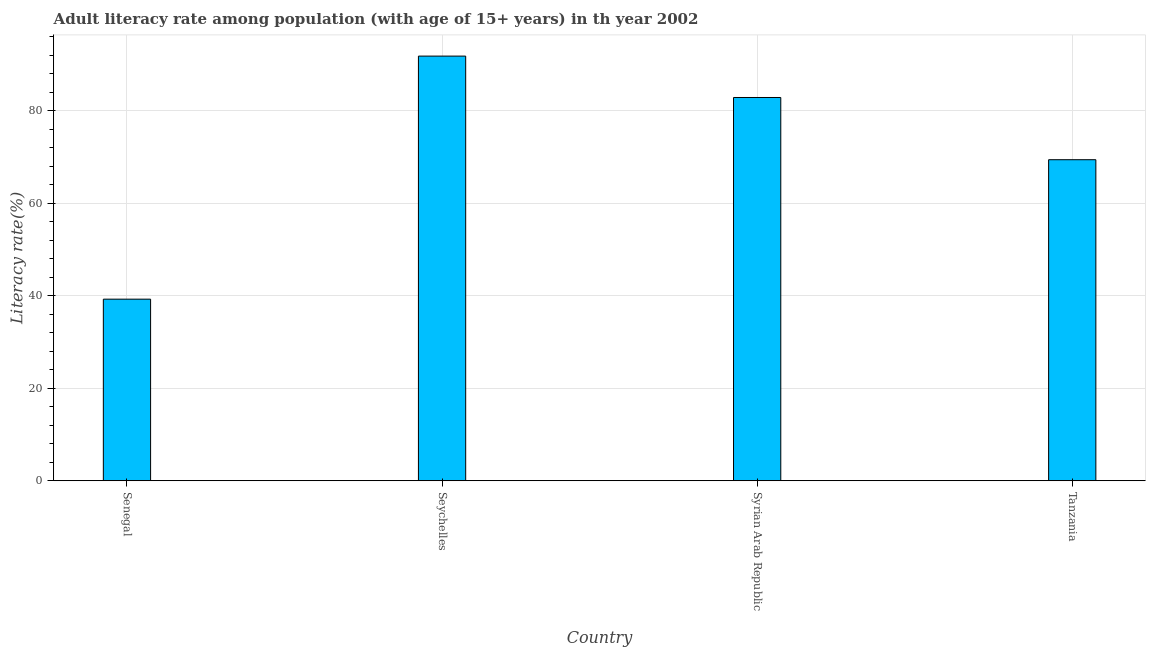What is the title of the graph?
Keep it short and to the point. Adult literacy rate among population (with age of 15+ years) in th year 2002. What is the label or title of the Y-axis?
Your response must be concise. Literacy rate(%). What is the adult literacy rate in Syrian Arab Republic?
Give a very brief answer. 82.89. Across all countries, what is the maximum adult literacy rate?
Offer a very short reply. 91.84. Across all countries, what is the minimum adult literacy rate?
Your response must be concise. 39.28. In which country was the adult literacy rate maximum?
Your response must be concise. Seychelles. In which country was the adult literacy rate minimum?
Offer a terse response. Senegal. What is the sum of the adult literacy rate?
Provide a succinct answer. 283.43. What is the difference between the adult literacy rate in Syrian Arab Republic and Tanzania?
Your response must be concise. 13.46. What is the average adult literacy rate per country?
Give a very brief answer. 70.86. What is the median adult literacy rate?
Offer a terse response. 76.16. In how many countries, is the adult literacy rate greater than 56 %?
Offer a terse response. 3. What is the ratio of the adult literacy rate in Senegal to that in Seychelles?
Provide a succinct answer. 0.43. What is the difference between the highest and the second highest adult literacy rate?
Give a very brief answer. 8.95. Is the sum of the adult literacy rate in Syrian Arab Republic and Tanzania greater than the maximum adult literacy rate across all countries?
Your answer should be compact. Yes. What is the difference between the highest and the lowest adult literacy rate?
Provide a succinct answer. 52.56. In how many countries, is the adult literacy rate greater than the average adult literacy rate taken over all countries?
Your answer should be very brief. 2. Are all the bars in the graph horizontal?
Give a very brief answer. No. Are the values on the major ticks of Y-axis written in scientific E-notation?
Your answer should be compact. No. What is the Literacy rate(%) in Senegal?
Your response must be concise. 39.28. What is the Literacy rate(%) of Seychelles?
Keep it short and to the point. 91.84. What is the Literacy rate(%) in Syrian Arab Republic?
Provide a short and direct response. 82.89. What is the Literacy rate(%) of Tanzania?
Your response must be concise. 69.43. What is the difference between the Literacy rate(%) in Senegal and Seychelles?
Your answer should be very brief. -52.56. What is the difference between the Literacy rate(%) in Senegal and Syrian Arab Republic?
Ensure brevity in your answer.  -43.61. What is the difference between the Literacy rate(%) in Senegal and Tanzania?
Your response must be concise. -30.16. What is the difference between the Literacy rate(%) in Seychelles and Syrian Arab Republic?
Provide a short and direct response. 8.95. What is the difference between the Literacy rate(%) in Seychelles and Tanzania?
Ensure brevity in your answer.  22.41. What is the difference between the Literacy rate(%) in Syrian Arab Republic and Tanzania?
Offer a terse response. 13.46. What is the ratio of the Literacy rate(%) in Senegal to that in Seychelles?
Ensure brevity in your answer.  0.43. What is the ratio of the Literacy rate(%) in Senegal to that in Syrian Arab Republic?
Make the answer very short. 0.47. What is the ratio of the Literacy rate(%) in Senegal to that in Tanzania?
Offer a terse response. 0.57. What is the ratio of the Literacy rate(%) in Seychelles to that in Syrian Arab Republic?
Your response must be concise. 1.11. What is the ratio of the Literacy rate(%) in Seychelles to that in Tanzania?
Keep it short and to the point. 1.32. What is the ratio of the Literacy rate(%) in Syrian Arab Republic to that in Tanzania?
Keep it short and to the point. 1.19. 